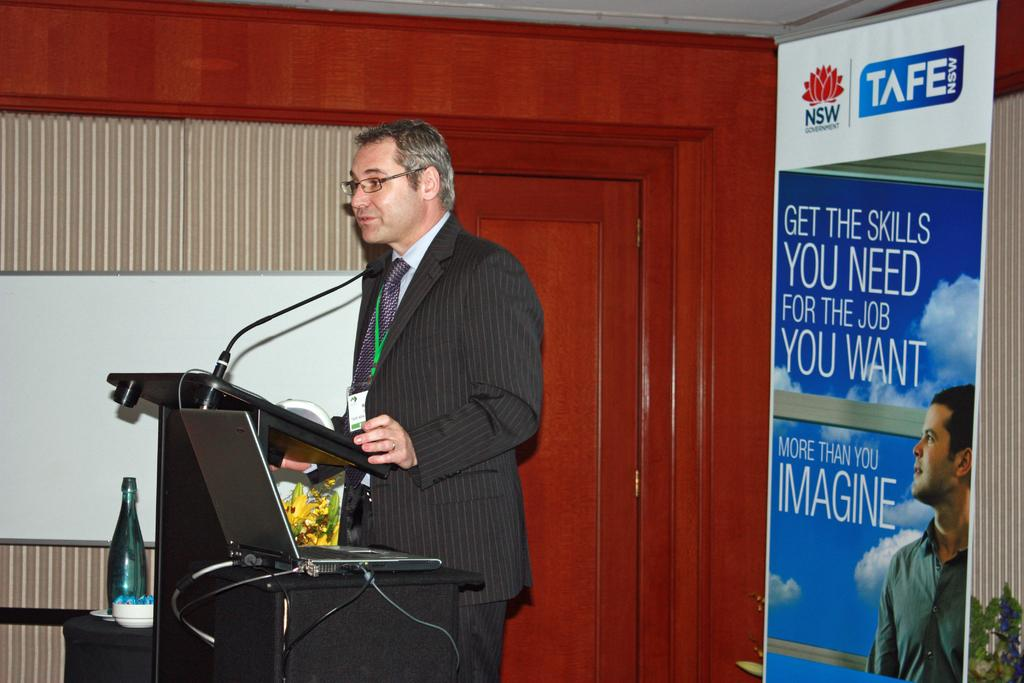What is the man in the image doing? The man is standing at the lectern in the image. What can be seen in the background of the image? There is a door, a display screen, an advertising board, a laptop, cables, a side table, and a glass bottle visible in the background. Reasoning: Let'g: Let's think step by step in order to produce the conversation. We start by identifying the main subject in the image, which is the man standing at the lectern. Then, we expand the conversation to include other items that are also visible in the background, ensuring that each question can be answered definitively with the information given. Absurd Question/Answer: What type of yoke is being used by the man in the image? There is no yoke present in the image. What type of humor is being displayed on the advertising board in the image? There is no humor present on the advertising board in the image; it is an advertisement for a product or service. Can you see the man's pocket in the image? The man's pocket is not visible in the image, as the focus is on the man standing at the lectern and the items in the background. 